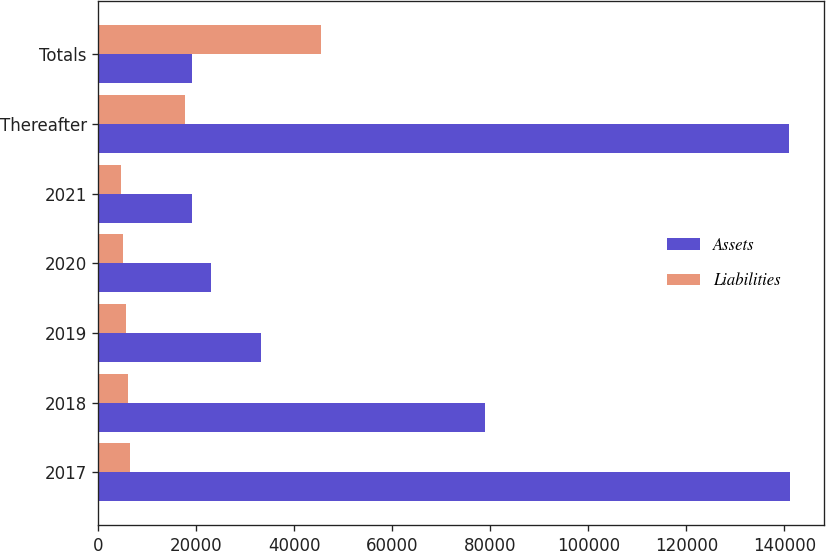Convert chart. <chart><loc_0><loc_0><loc_500><loc_500><stacked_bar_chart><ecel><fcel>2017<fcel>2018<fcel>2019<fcel>2020<fcel>2021<fcel>Thereafter<fcel>Totals<nl><fcel>Assets<fcel>141094<fcel>78905<fcel>33228<fcel>22958<fcel>19045<fcel>140940<fcel>19045<nl><fcel>Liabilities<fcel>6544<fcel>5959<fcel>5551<fcel>5074<fcel>4586<fcel>17727<fcel>45441<nl></chart> 